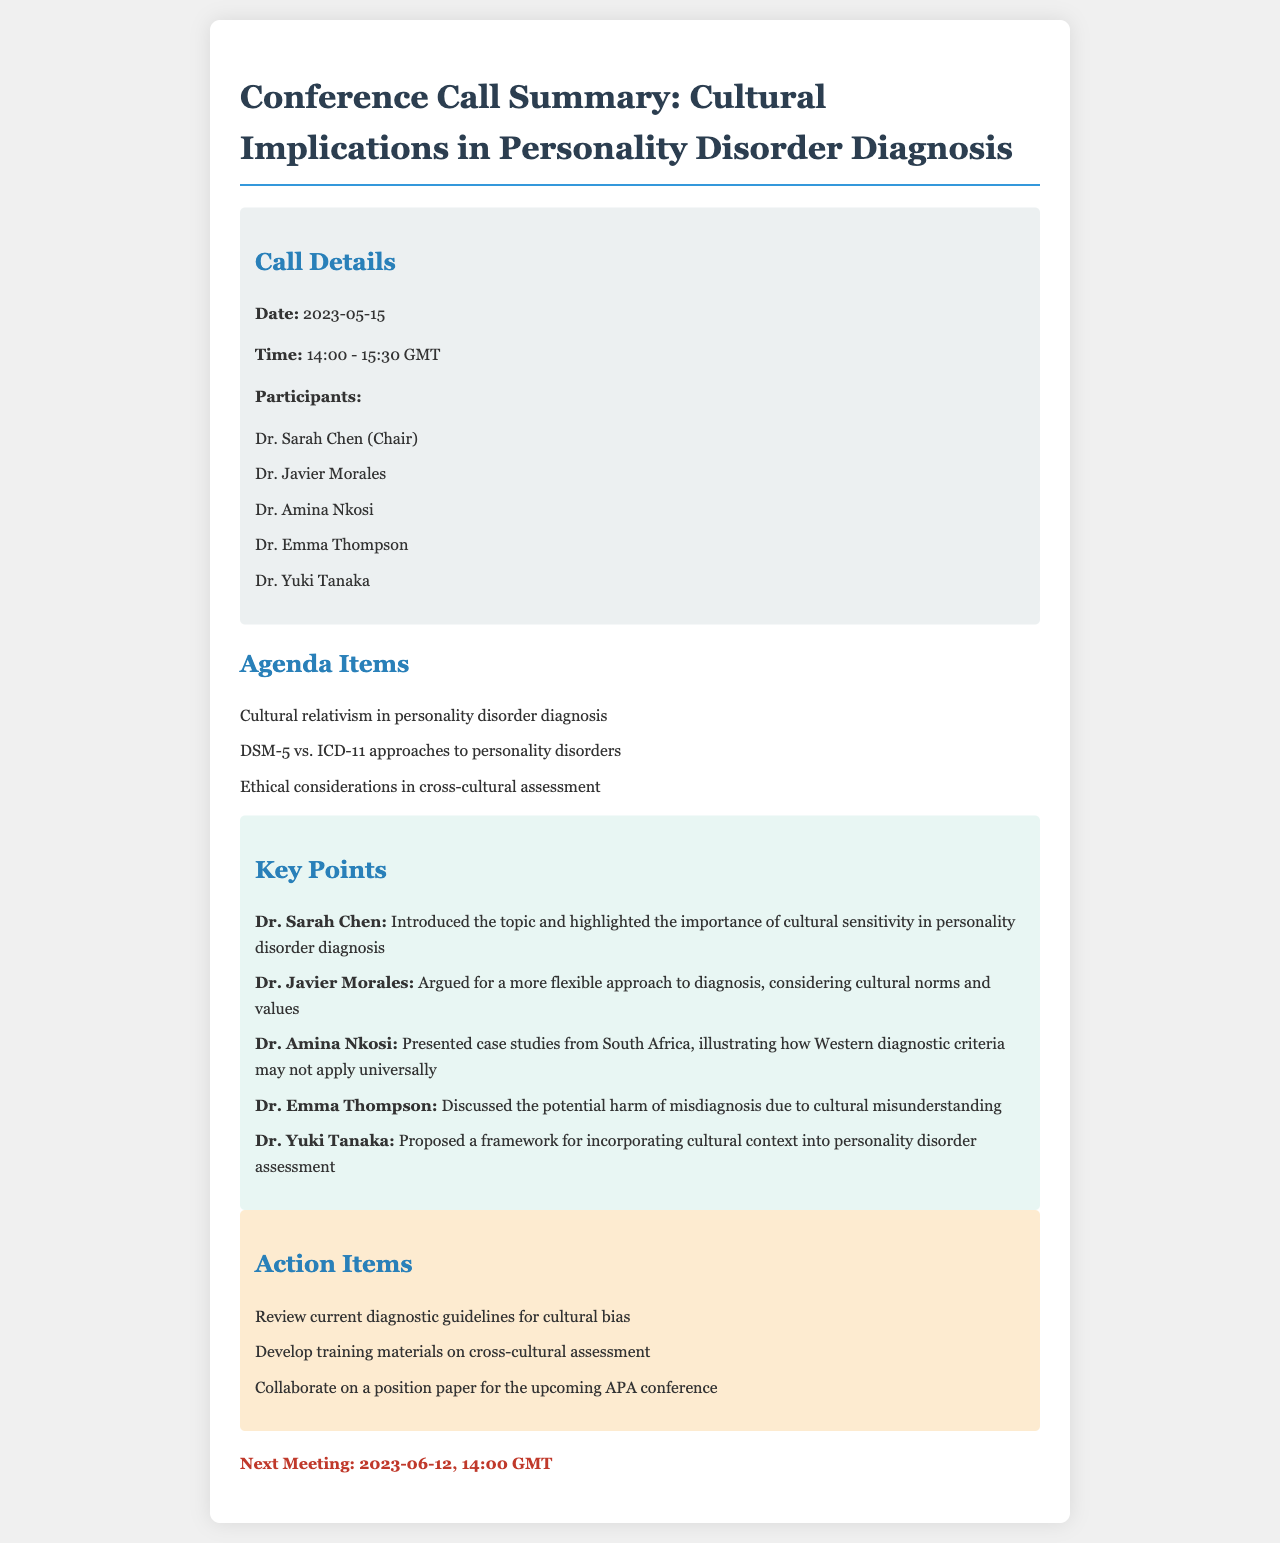What is the date of the conference call? The date is specified in the call details section of the document.
Answer: 2023-05-15 Who chaired the conference call? The chair of the conference call is mentioned in the call details section.
Answer: Dr. Sarah Chen What is one of the agenda items discussed? The agenda items are listed in the agenda section of the document.
Answer: Cultural relativism in personality disorder diagnosis Which framework did Dr. Yuki Tanaka propose? The proposed framework is mentioned in the key points section.
Answer: Incorporating cultural context into personality disorder assessment What is the next meeting date? The next meeting date is provided at the bottom of the document.
Answer: 2023-06-12 Who presented case studies from South Africa? The presenter of the case studies is named in the key points section.
Answer: Dr. Amina Nkosi What is one action item from the call? Action items are listed in the action items section.
Answer: Review current diagnostic guidelines for cultural bias 